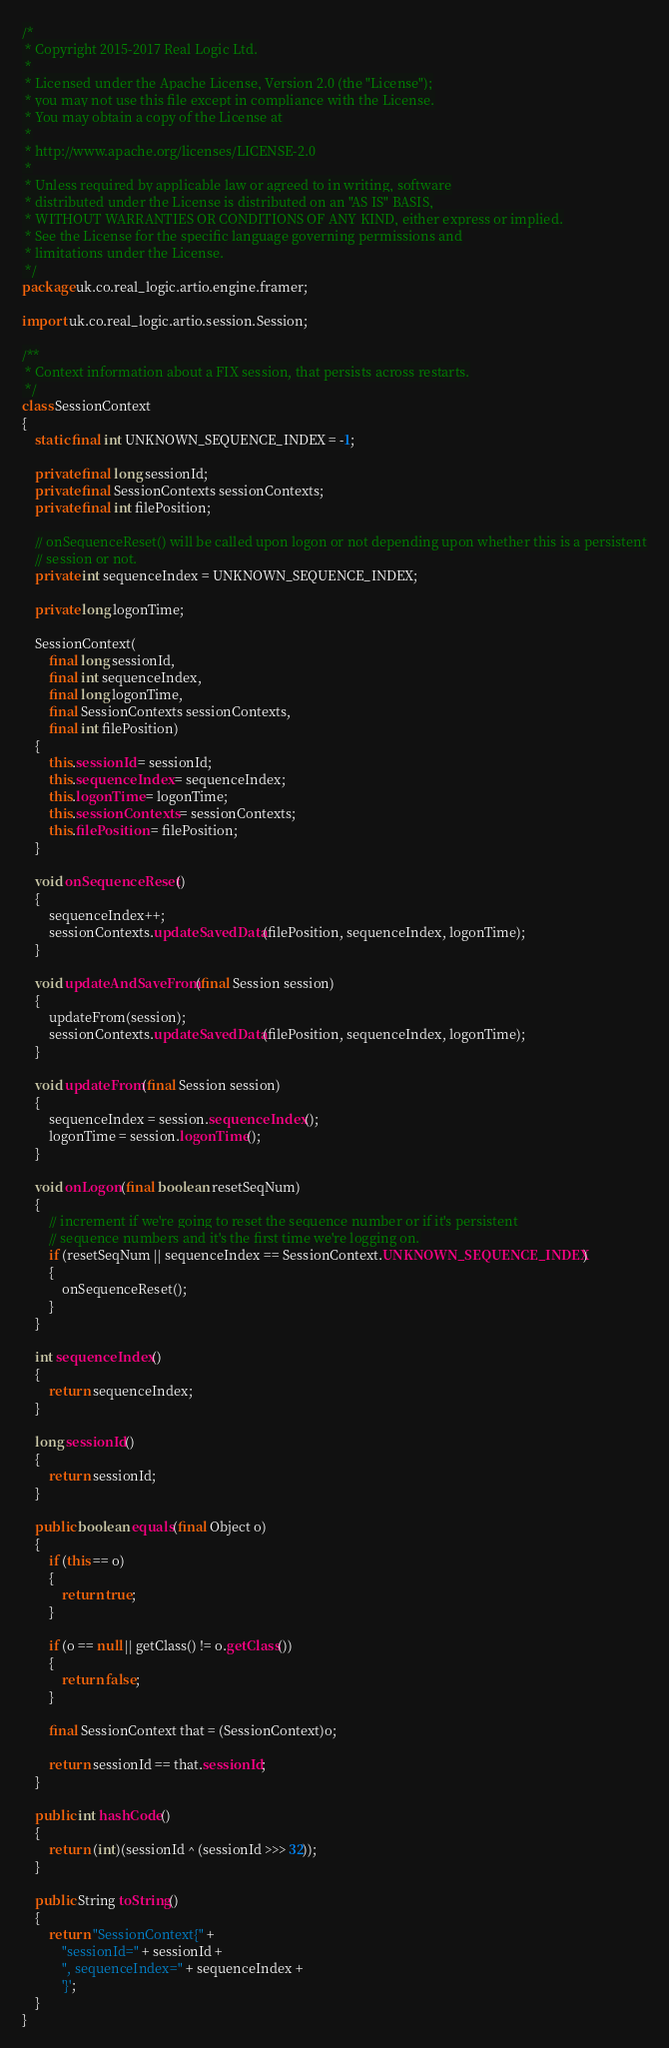Convert code to text. <code><loc_0><loc_0><loc_500><loc_500><_Java_>/*
 * Copyright 2015-2017 Real Logic Ltd.
 *
 * Licensed under the Apache License, Version 2.0 (the "License");
 * you may not use this file except in compliance with the License.
 * You may obtain a copy of the License at
 *
 * http://www.apache.org/licenses/LICENSE-2.0
 *
 * Unless required by applicable law or agreed to in writing, software
 * distributed under the License is distributed on an "AS IS" BASIS,
 * WITHOUT WARRANTIES OR CONDITIONS OF ANY KIND, either express or implied.
 * See the License for the specific language governing permissions and
 * limitations under the License.
 */
package uk.co.real_logic.artio.engine.framer;

import uk.co.real_logic.artio.session.Session;

/**
 * Context information about a FIX session, that persists across restarts.
 */
class SessionContext
{
    static final int UNKNOWN_SEQUENCE_INDEX = -1;

    private final long sessionId;
    private final SessionContexts sessionContexts;
    private final int filePosition;

    // onSequenceReset() will be called upon logon or not depending upon whether this is a persistent
    // session or not.
    private int sequenceIndex = UNKNOWN_SEQUENCE_INDEX;

    private long logonTime;

    SessionContext(
        final long sessionId,
        final int sequenceIndex,
        final long logonTime,
        final SessionContexts sessionContexts,
        final int filePosition)
    {
        this.sessionId = sessionId;
        this.sequenceIndex = sequenceIndex;
        this.logonTime = logonTime;
        this.sessionContexts = sessionContexts;
        this.filePosition = filePosition;
    }

    void onSequenceReset()
    {
        sequenceIndex++;
        sessionContexts.updateSavedData(filePosition, sequenceIndex, logonTime);
    }

    void updateAndSaveFrom(final Session session)
    {
        updateFrom(session);
        sessionContexts.updateSavedData(filePosition, sequenceIndex, logonTime);
    }

    void updateFrom(final Session session)
    {
        sequenceIndex = session.sequenceIndex();
        logonTime = session.logonTime();
    }

    void onLogon(final boolean resetSeqNum)
    {
        // increment if we're going to reset the sequence number or if it's persistent
        // sequence numbers and it's the first time we're logging on.
        if (resetSeqNum || sequenceIndex == SessionContext.UNKNOWN_SEQUENCE_INDEX)
        {
            onSequenceReset();
        }
    }

    int sequenceIndex()
    {
        return sequenceIndex;
    }

    long sessionId()
    {
        return sessionId;
    }

    public boolean equals(final Object o)
    {
        if (this == o)
        {
            return true;
        }

        if (o == null || getClass() != o.getClass())
        {
            return false;
        }

        final SessionContext that = (SessionContext)o;

        return sessionId == that.sessionId;
    }

    public int hashCode()
    {
        return (int)(sessionId ^ (sessionId >>> 32));
    }

    public String toString()
    {
        return "SessionContext{" +
            "sessionId=" + sessionId +
            ", sequenceIndex=" + sequenceIndex +
            '}';
    }
}
</code> 